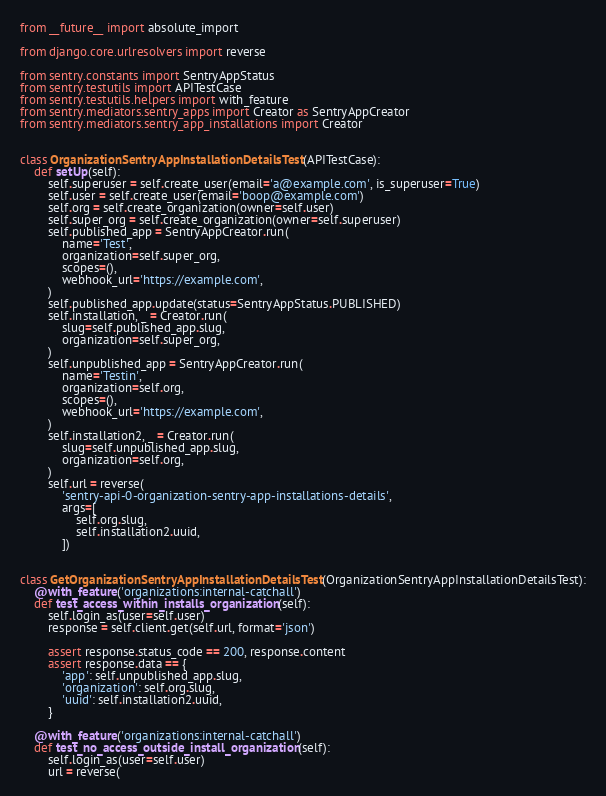<code> <loc_0><loc_0><loc_500><loc_500><_Python_>from __future__ import absolute_import

from django.core.urlresolvers import reverse

from sentry.constants import SentryAppStatus
from sentry.testutils import APITestCase
from sentry.testutils.helpers import with_feature
from sentry.mediators.sentry_apps import Creator as SentryAppCreator
from sentry.mediators.sentry_app_installations import Creator


class OrganizationSentryAppInstallationDetailsTest(APITestCase):
    def setUp(self):
        self.superuser = self.create_user(email='a@example.com', is_superuser=True)
        self.user = self.create_user(email='boop@example.com')
        self.org = self.create_organization(owner=self.user)
        self.super_org = self.create_organization(owner=self.superuser)
        self.published_app = SentryAppCreator.run(
            name='Test',
            organization=self.super_org,
            scopes=(),
            webhook_url='https://example.com',
        )
        self.published_app.update(status=SentryAppStatus.PUBLISHED)
        self.installation, _ = Creator.run(
            slug=self.published_app.slug,
            organization=self.super_org,
        )
        self.unpublished_app = SentryAppCreator.run(
            name='Testin',
            organization=self.org,
            scopes=(),
            webhook_url='https://example.com',
        )
        self.installation2, _ = Creator.run(
            slug=self.unpublished_app.slug,
            organization=self.org,
        )
        self.url = reverse(
            'sentry-api-0-organization-sentry-app-installations-details',
            args=[
                self.org.slug,
                self.installation2.uuid,
            ])


class GetOrganizationSentryAppInstallationDetailsTest(OrganizationSentryAppInstallationDetailsTest):
    @with_feature('organizations:internal-catchall')
    def test_access_within_installs_organization(self):
        self.login_as(user=self.user)
        response = self.client.get(self.url, format='json')

        assert response.status_code == 200, response.content
        assert response.data == {
            'app': self.unpublished_app.slug,
            'organization': self.org.slug,
            'uuid': self.installation2.uuid,
        }

    @with_feature('organizations:internal-catchall')
    def test_no_access_outside_install_organization(self):
        self.login_as(user=self.user)
        url = reverse(</code> 